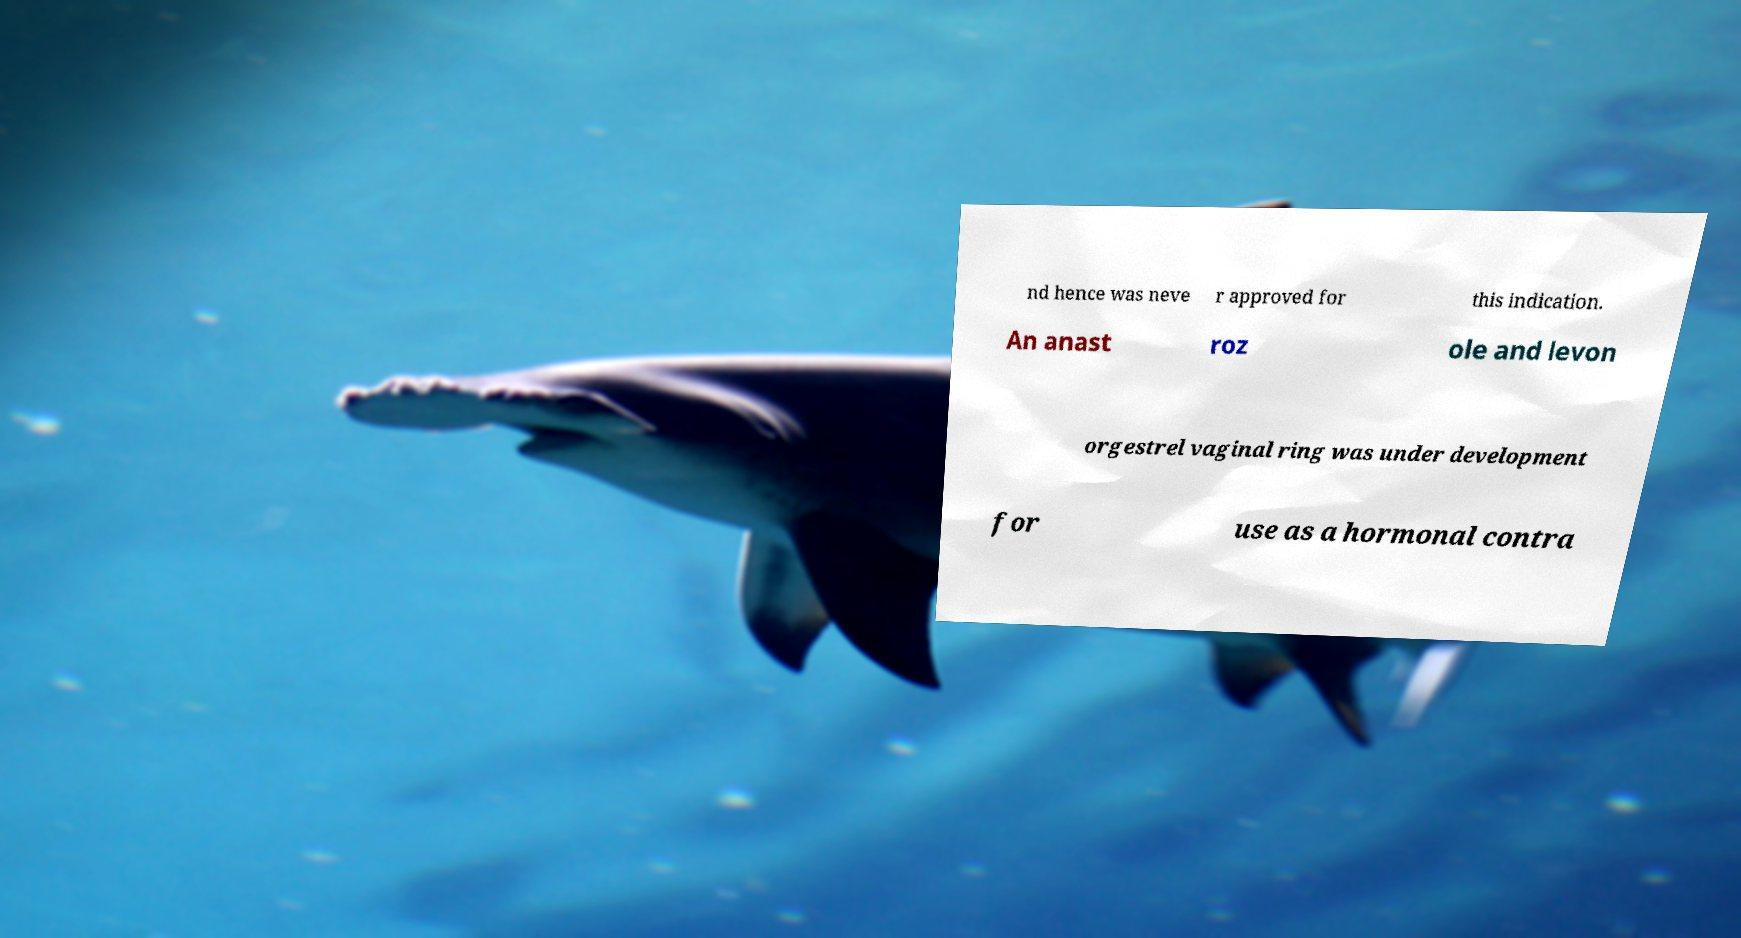Can you accurately transcribe the text from the provided image for me? nd hence was neve r approved for this indication. An anast roz ole and levon orgestrel vaginal ring was under development for use as a hormonal contra 